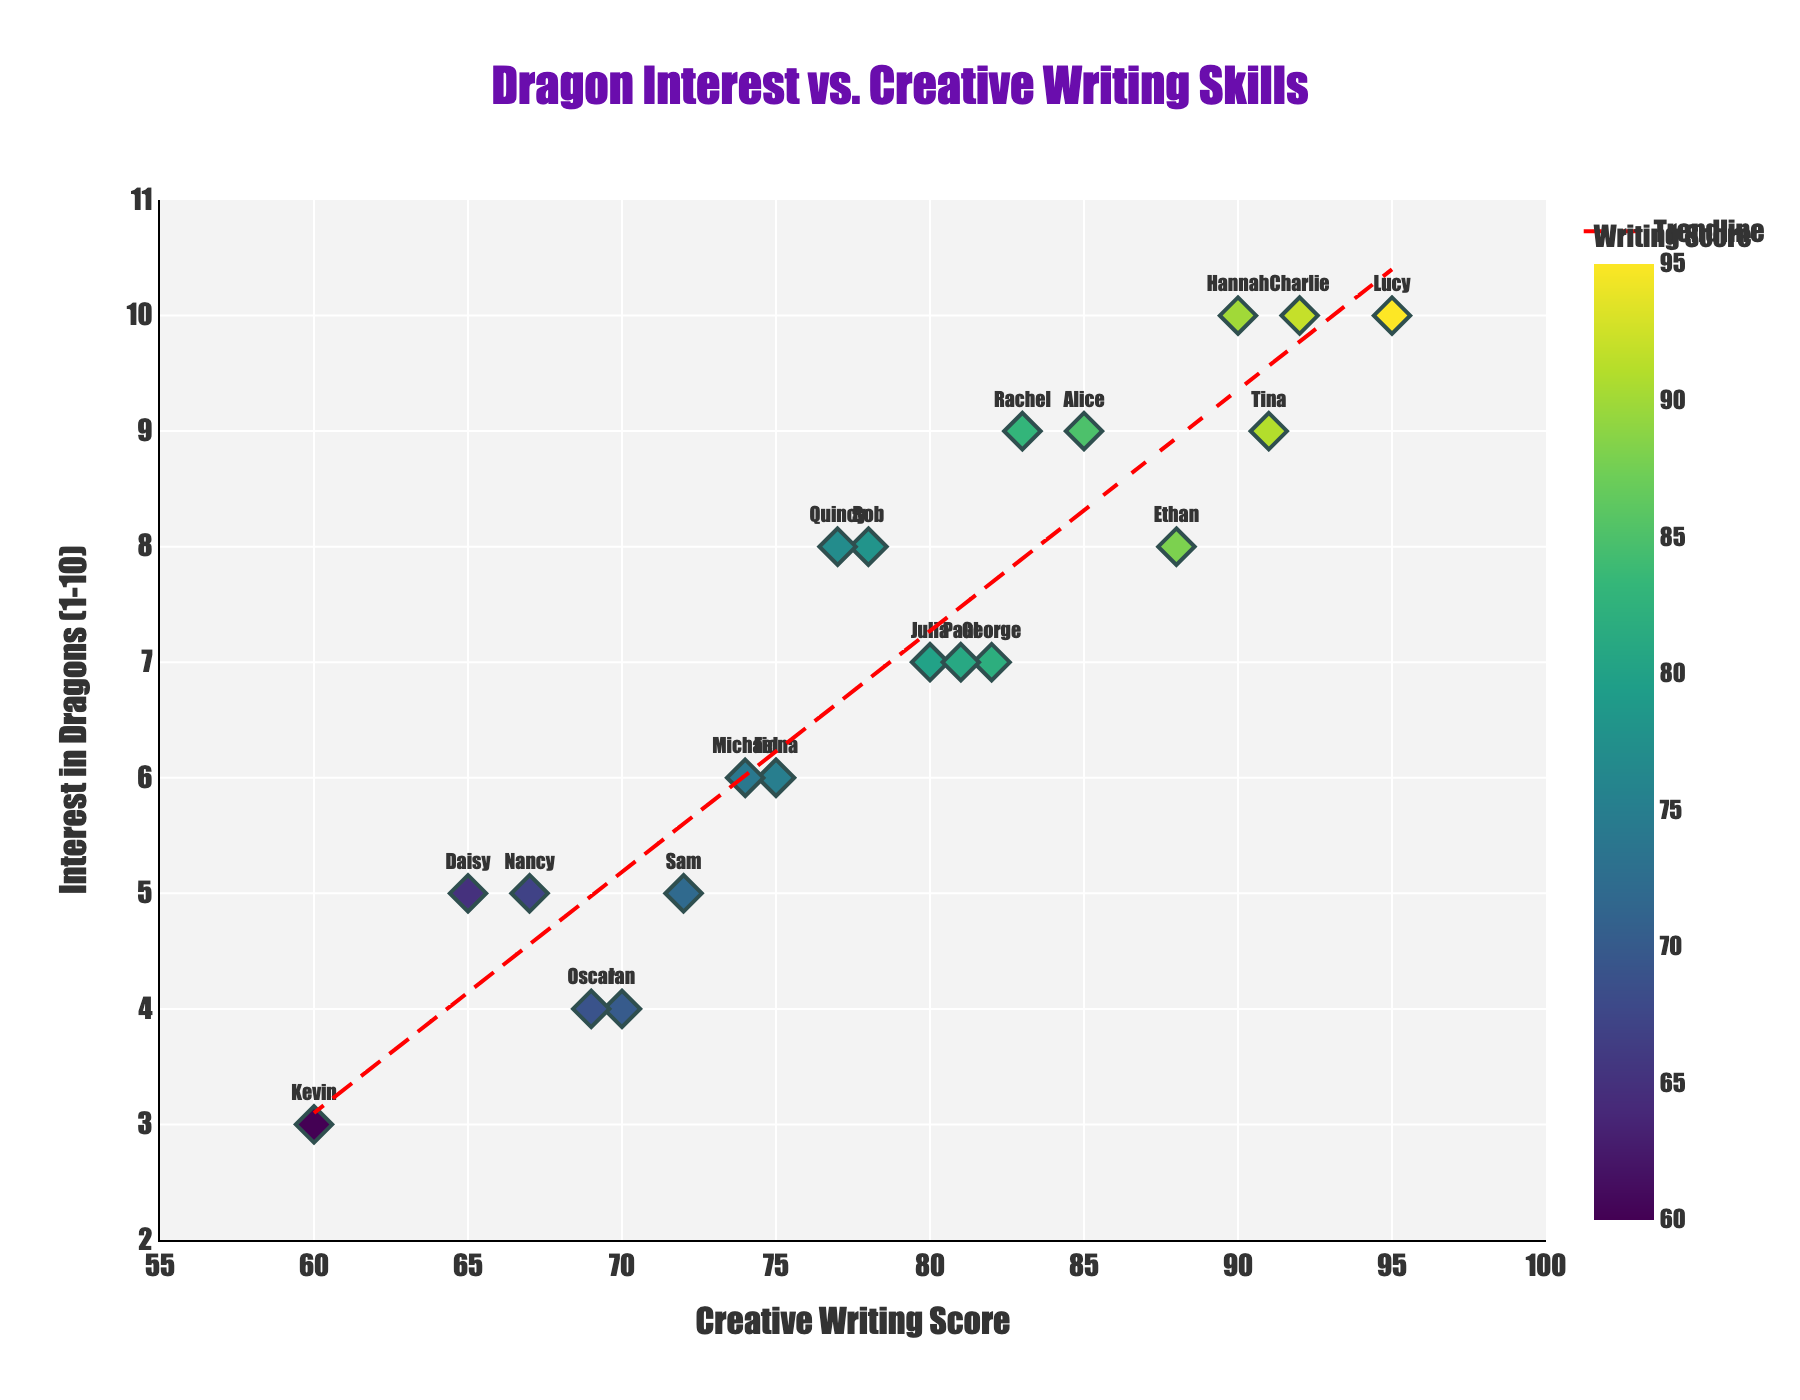what is the title of the figure? The title of the figure can be found at the top center of the plot. It provides a clear summary of what the plot represents.
Answer: Dragon Interest vs. Creative Writing Skills How many children have an Interest in Dragons score of 10? Count the points that align with an Interest in Dragons (1-10) value of 10.
Answer: 3 Which child has the highest Creative Writing Score? Look for the highest value on the Creative Writing Score axis and identify the corresponding child name shown next to the data point.
Answer: Lucy What is the range of the Creative Writing Scores among the children? To determine the range, find the minimum and maximum creative writing scores and subtract the minimum from the maximum (95 - 60).
Answer: 35 What is the trendline indicating about the relationship between Creative Writing Scores and Interest in Dragons? Observe the direction of the trendline. If it slopes upwards, it indicates a positive correlation where higher writing scores are generally associated with higher interest in dragons.
Answer: Positive correlation Identify the child with a Creative Writing Score of 74. Find the data point with a Creative Writing Score of 74 and look at the name displayed near that point.
Answer: Michael What is the average Creative Writing Score of children with an Interest in Dragons score of 8? Identify all the children with a score of 8, sum their Creative Writing Scores, then divide by the number of such children ((78+88+77)/3).
Answer: 81 How does Paul’s interest in dragons compare to Bob’s? Locate Paul and Bob's data points; compare their Interest in Dragons scores to see which is higher.
Answer: Paul's interest (7) is less than Bob's (8) Who has a Creative Writing Score closest to 80? Look for the data points near the Creative Writing Score of 80 and identify the child's name displayed closest to this value.
Answer: Julia Between children with higher than average Creative Writing Scores (above 80), what is the mean Interest in Dragons score? Identify children with scores above 80, sum their Interest in Dragons scores, and divide by the number of such children to find the mean. ((9+10+8+7+10+10+7+9+9)/9).
Answer: 8.77 